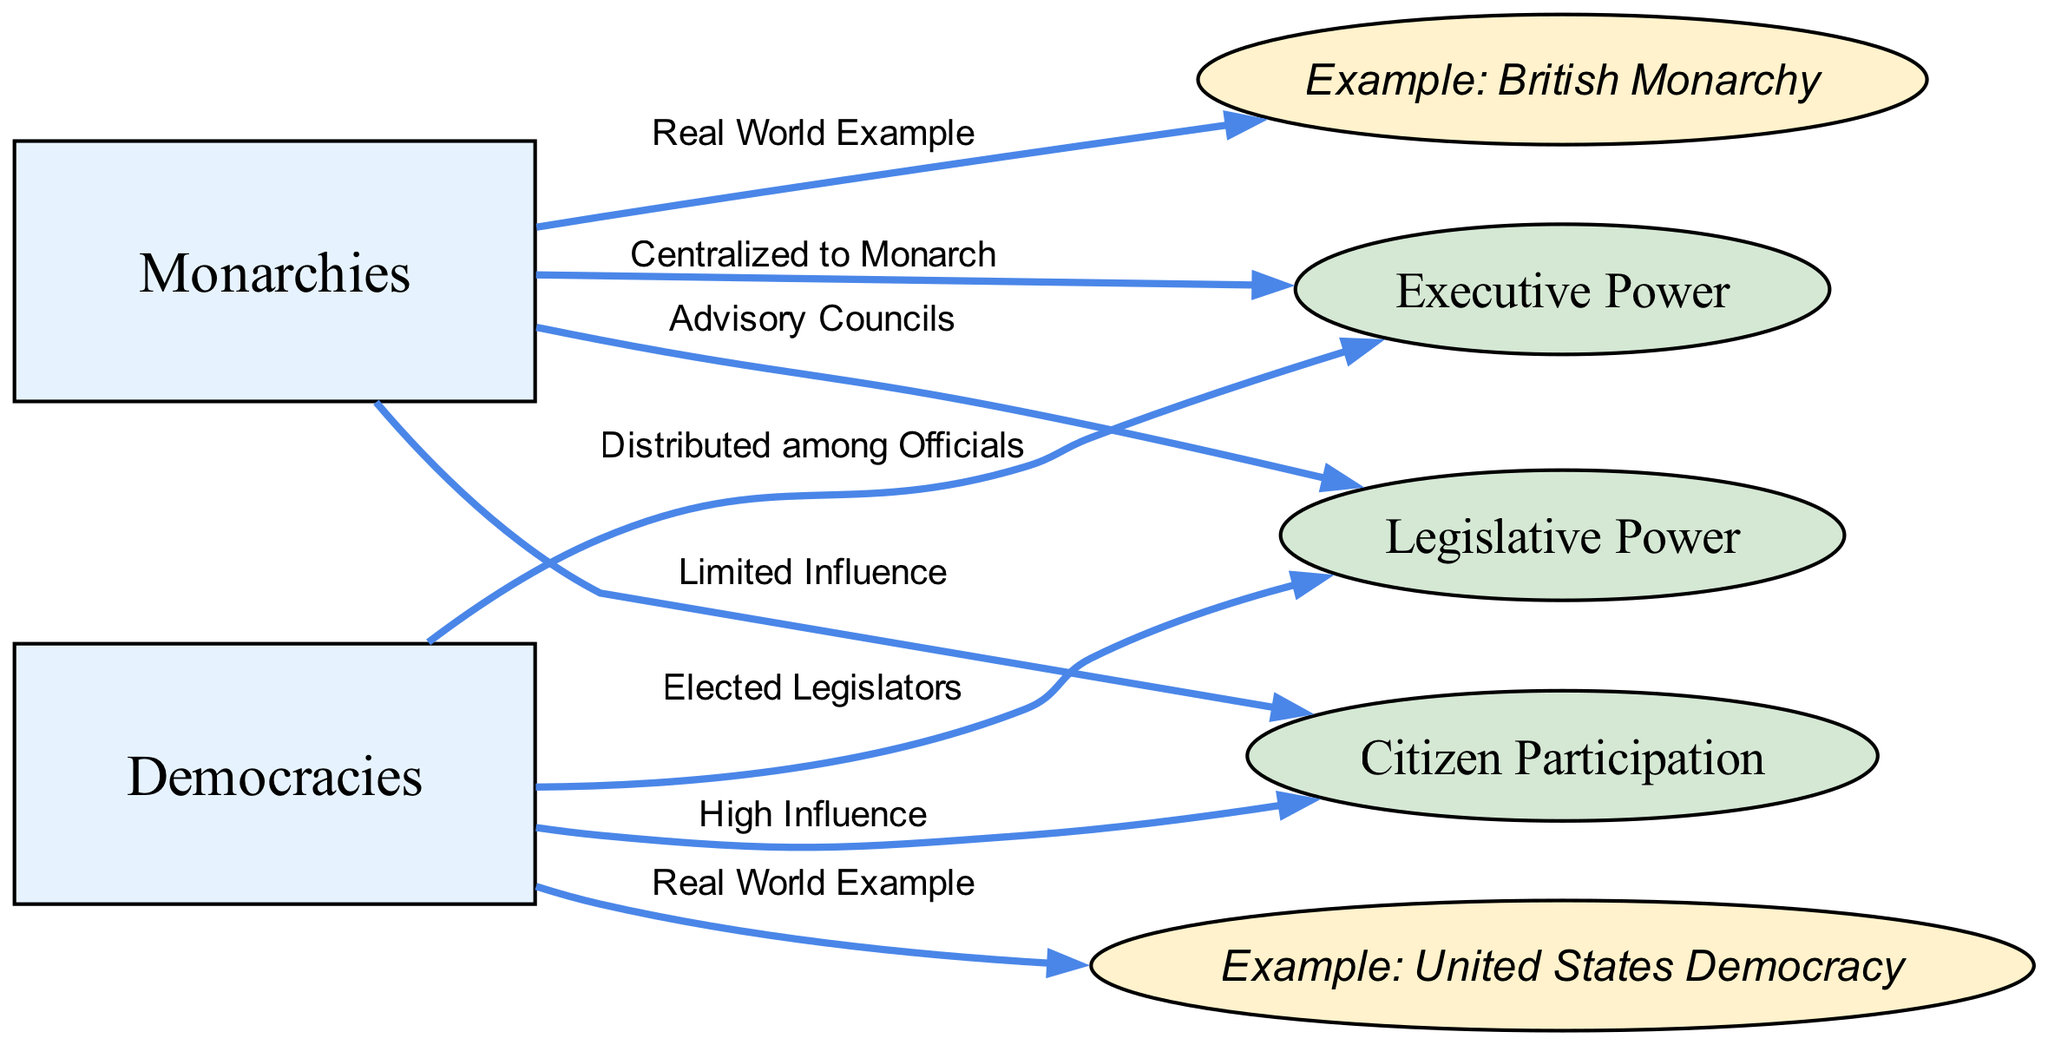What is the primary structure of executive power in monarchies? The diagram shows that the executive power in monarchies is described as "Centralized to Monarch." This indicates that the monarch holds the majority of the power and makes decisions centrally without much distribution.
Answer: Centralized to Monarch What example is given for democracies? The diagram lists "Example: United States Democracy" under the democracies node, indicating that it provides a real-world example of a democratic system and its functioning.
Answer: Example: United States Democracy How many nodes are there in total in the diagram? By counting the nodes mentioned in the diagram, including monarchies, democracies, and the related aspects like executive power, legislative power, and citizen participation, the total is six.
Answer: 6 What is the level of citizen participation in democracies according to the diagram? The diagram specifies that citizen participation in democracies is characterized as "High Influence," reflecting a greater degree of involvement in decision-making processes compared to monarchies.
Answer: High Influence What type of legislative power exists in monarchies? The diagram indicates that the legislative power in monarchies is represented as "Advisory Councils," suggesting that there may be some form of council, but ultimate power lies with the monarch.
Answer: Advisory Councils What relationship does the diagram imply between monarchies and citizen participation? The diagram connects monarchies to "Limited Influence" in citizen participation, which suggests that the role and power of citizens in influencing governance is quite restricted compared to other systems.
Answer: Limited Influence What is the difference in distribution of executive power between monarchies and democracies? According to the diagram, the distribution of executive power in monarchies is "Centralized to Monarch," while in democracies, it is "Distributed among Officials," indicating a key difference in how power is shared and exercised.
Answer: Centralized to Monarch; Distributed among Officials How is legislative power characterized in democracies? The diagram states that the legislative power in democracies involves "Elected Legislators," which implies that the representatives are chosen through elections and are accountable to the citizens.
Answer: Elected Legislators What visual representation indicates a real-world example in the diagram? The diagram uses ellipses to represent real-world examples, specifically labeling "Example: British Monarchy" and "Example: United States Democracy" as direct illustrations of monarchical and democratic systems respectively.
Answer: Example: British Monarchy; Example: United States Democracy 